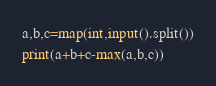Convert code to text. <code><loc_0><loc_0><loc_500><loc_500><_Python_>a,b,c=map(int,input().split())
print(a+b+c-max(a,b,c))</code> 